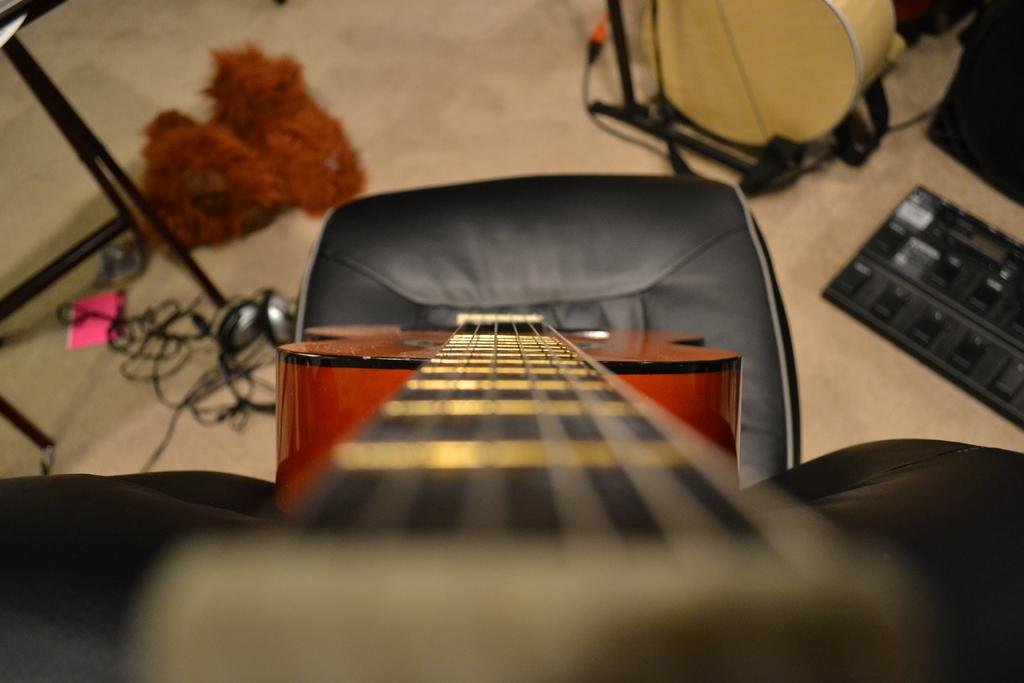What musical instrument is visible in the image? There is a guitar in the image. How is the guitar positioned in the image? The guitar is placed on a chair. What other musical instrument can be seen in the image? There is a drum in the image. How is the drum supported in the image? The drum is placed on a drum stand. What non-musical item is present in the image? There is a toy in the image. What type of headphones are visible in the image? There is a headset in the image. What additional items can be seen in the image? There are cables and a paper in the image. What type of mass can be seen controlling the guitar in the image? There is no mass or person controlling the guitar in the image; it is simply placed on a chair. 